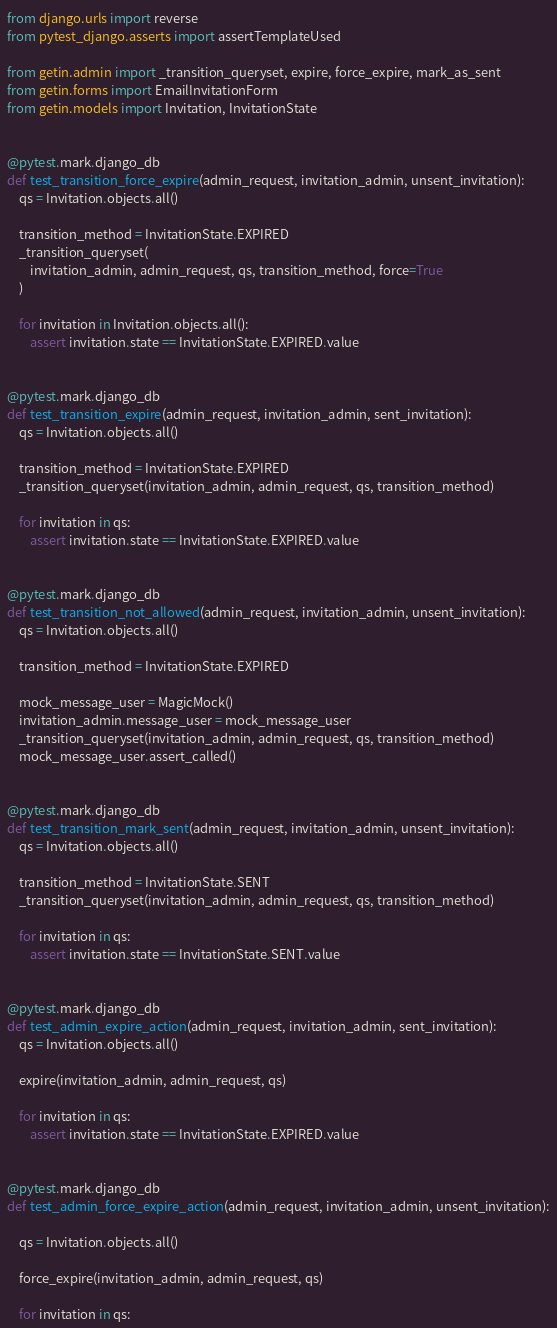Convert code to text. <code><loc_0><loc_0><loc_500><loc_500><_Python_>from django.urls import reverse
from pytest_django.asserts import assertTemplateUsed

from getin.admin import _transition_queryset, expire, force_expire, mark_as_sent
from getin.forms import EmailInvitationForm
from getin.models import Invitation, InvitationState


@pytest.mark.django_db
def test_transition_force_expire(admin_request, invitation_admin, unsent_invitation):
    qs = Invitation.objects.all()

    transition_method = InvitationState.EXPIRED
    _transition_queryset(
        invitation_admin, admin_request, qs, transition_method, force=True
    )

    for invitation in Invitation.objects.all():
        assert invitation.state == InvitationState.EXPIRED.value


@pytest.mark.django_db
def test_transition_expire(admin_request, invitation_admin, sent_invitation):
    qs = Invitation.objects.all()

    transition_method = InvitationState.EXPIRED
    _transition_queryset(invitation_admin, admin_request, qs, transition_method)

    for invitation in qs:
        assert invitation.state == InvitationState.EXPIRED.value


@pytest.mark.django_db
def test_transition_not_allowed(admin_request, invitation_admin, unsent_invitation):
    qs = Invitation.objects.all()

    transition_method = InvitationState.EXPIRED

    mock_message_user = MagicMock()
    invitation_admin.message_user = mock_message_user
    _transition_queryset(invitation_admin, admin_request, qs, transition_method)
    mock_message_user.assert_called()


@pytest.mark.django_db
def test_transition_mark_sent(admin_request, invitation_admin, unsent_invitation):
    qs = Invitation.objects.all()

    transition_method = InvitationState.SENT
    _transition_queryset(invitation_admin, admin_request, qs, transition_method)

    for invitation in qs:
        assert invitation.state == InvitationState.SENT.value


@pytest.mark.django_db
def test_admin_expire_action(admin_request, invitation_admin, sent_invitation):
    qs = Invitation.objects.all()

    expire(invitation_admin, admin_request, qs)

    for invitation in qs:
        assert invitation.state == InvitationState.EXPIRED.value


@pytest.mark.django_db
def test_admin_force_expire_action(admin_request, invitation_admin, unsent_invitation):

    qs = Invitation.objects.all()

    force_expire(invitation_admin, admin_request, qs)

    for invitation in qs:</code> 